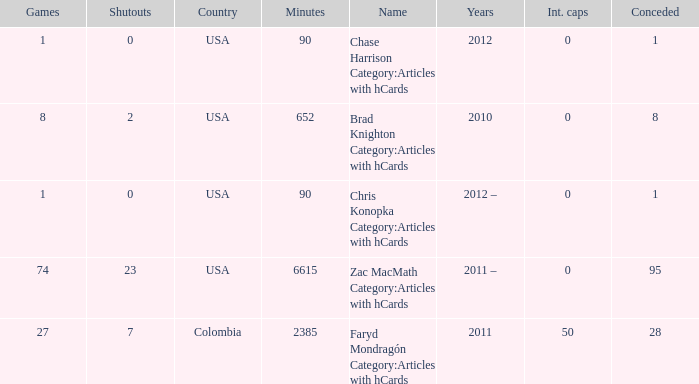When chase harrison category:articles with hcards is the name what is the year? 2012.0. Would you be able to parse every entry in this table? {'header': ['Games', 'Shutouts', 'Country', 'Minutes', 'Name', 'Years', 'Int. caps', 'Conceded'], 'rows': [['1', '0', 'USA', '90', 'Chase Harrison Category:Articles with hCards', '2012', '0', '1'], ['8', '2', 'USA', '652', 'Brad Knighton Category:Articles with hCards', '2010', '0', '8'], ['1', '0', 'USA', '90', 'Chris Konopka Category:Articles with hCards', '2012 –', '0', '1'], ['74', '23', 'USA', '6615', 'Zac MacMath Category:Articles with hCards', '2011 –', '0', '95'], ['27', '7', 'Colombia', '2385', 'Faryd Mondragón Category:Articles with hCards', '2011', '50', '28']]} 